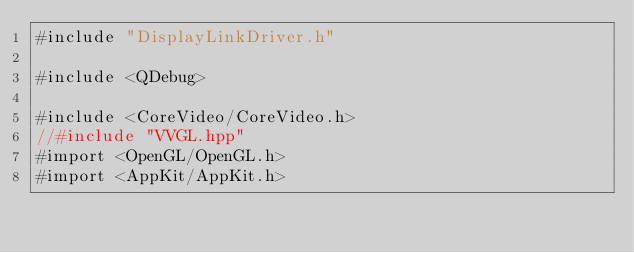Convert code to text. <code><loc_0><loc_0><loc_500><loc_500><_ObjectiveC_>#include "DisplayLinkDriver.h"

#include <QDebug>

#include <CoreVideo/CoreVideo.h>
//#include "VVGL.hpp"
#import <OpenGL/OpenGL.h>
#import <AppKit/AppKit.h>



</code> 